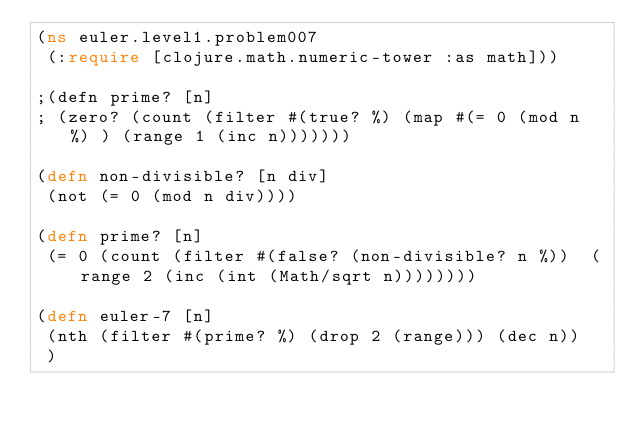<code> <loc_0><loc_0><loc_500><loc_500><_Clojure_>(ns euler.level1.problem007
 (:require [clojure.math.numeric-tower :as math]))

;(defn prime? [n]
; (zero? (count (filter #(true? %) (map #(= 0 (mod n %) ) (range 1 (inc n)))))))

(defn non-divisible? [n div]
 (not (= 0 (mod n div))))

(defn prime? [n]
 (= 0 (count (filter #(false? (non-divisible? n %))  (range 2 (inc (int (Math/sqrt n))))))))

(defn euler-7 [n]
 (nth (filter #(prime? %) (drop 2 (range))) (dec n))
 )
</code> 